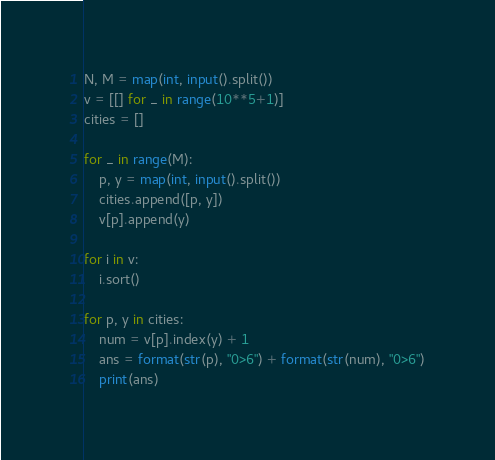Convert code to text. <code><loc_0><loc_0><loc_500><loc_500><_Python_>N, M = map(int, input().split())
v = [[] for _ in range(10**5+1)]
cities = []

for _ in range(M):
    p, y = map(int, input().split())
    cities.append([p, y])
    v[p].append(y)

for i in v:
    i.sort()

for p, y in cities:
    num = v[p].index(y) + 1
    ans = format(str(p), "0>6") + format(str(num), "0>6")
    print(ans)
</code> 